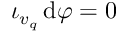Convert formula to latex. <formula><loc_0><loc_0><loc_500><loc_500>\iota _ { v _ { q } } \, d \varphi = 0</formula> 